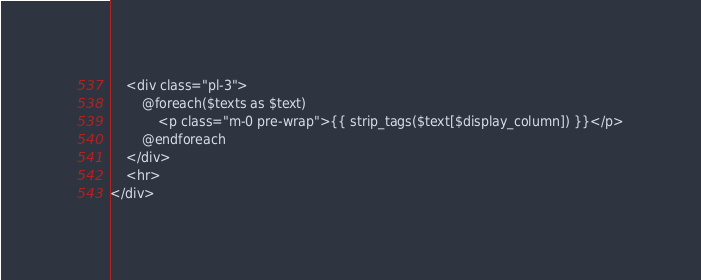Convert code to text. <code><loc_0><loc_0><loc_500><loc_500><_PHP_>	<div class="pl-3">
		@foreach($texts as $text)
			<p class="m-0 pre-wrap">{{ strip_tags($text[$display_column]) }}</p>
		@endforeach
	</div>
	<hr>
</div></code> 